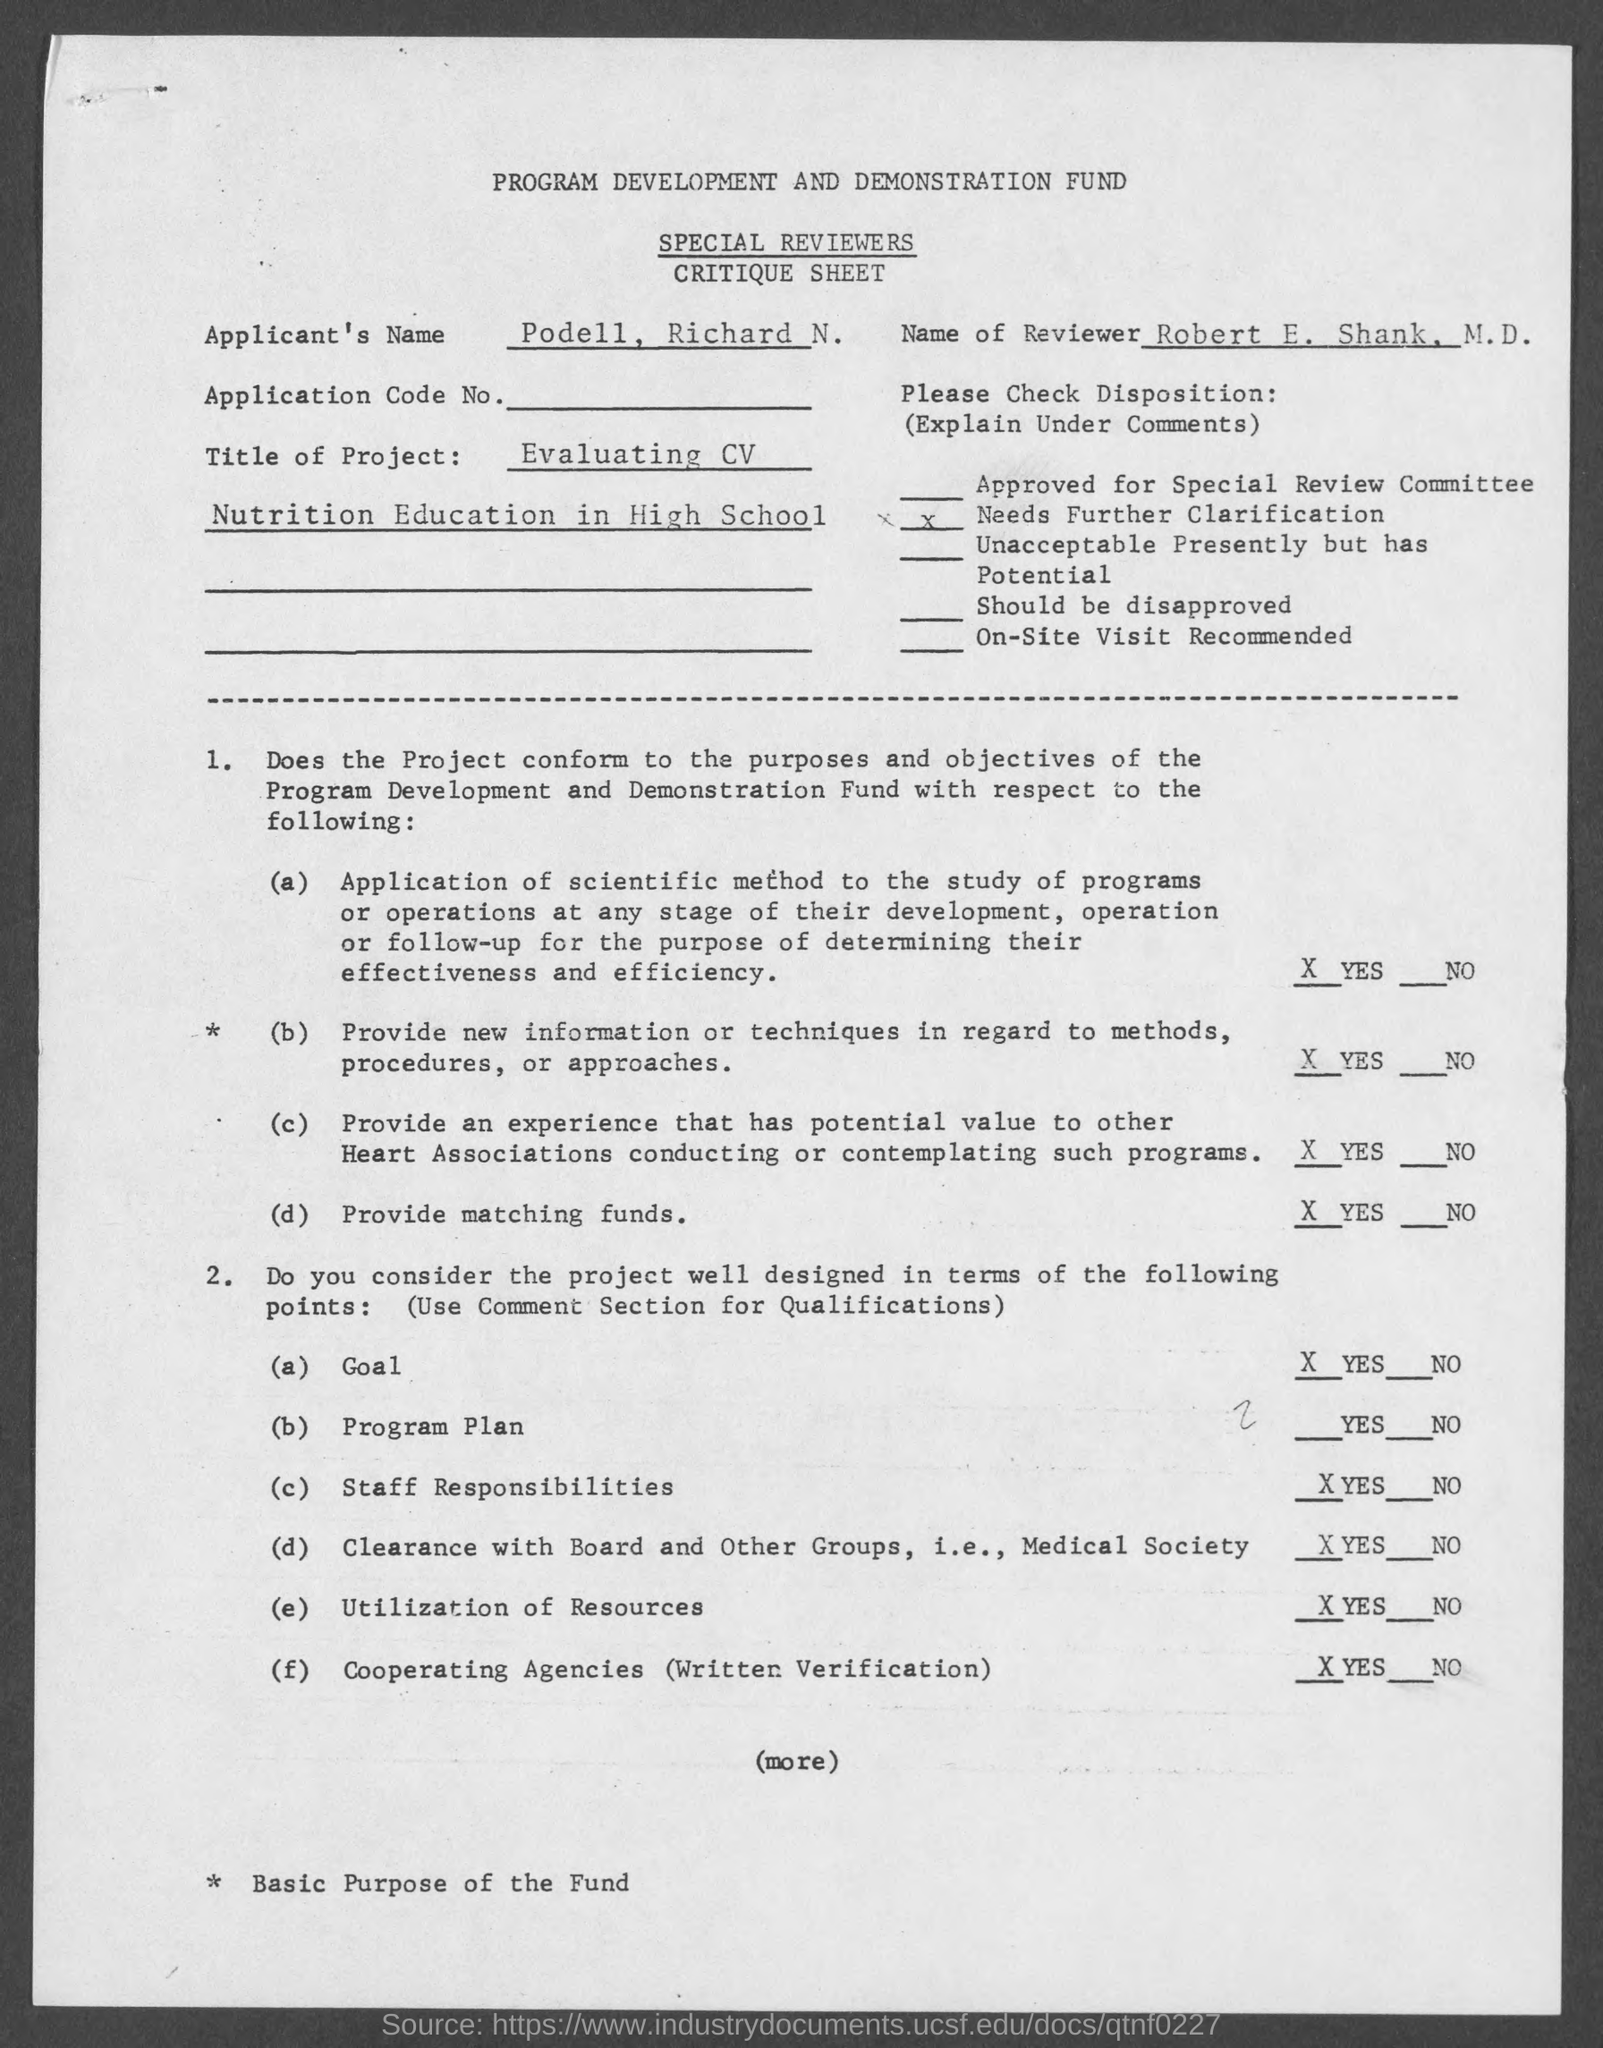Identify some key points in this picture. The given critique sheet mentions the name "Podell, Richard N." as the applicant. 